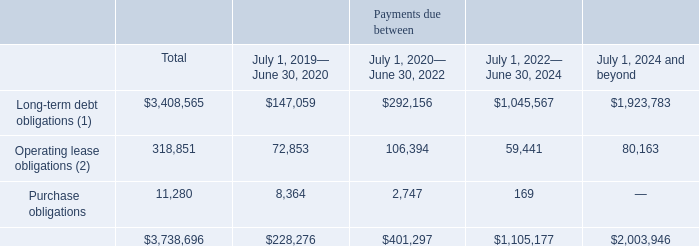NOTE 13—GUARANTEES AND CONTINGENCIES
We have entered into the following contractual obligations with minimum payments for the indicated fiscal periods as follows:
(1) Includes interest up to maturity and principal payments. Please see note 10 "Long-Term Debt" for more details
(2) Net of $30.7 million of sublease income to be received from properties which we have subleased to third parties.
What does the table represent? Contractual obligations with minimum payments for the indicated fiscal periods. What is Operating lease obligations net of? $30.7 million of sublease income. What does Long-term debt obligations include? Interest up to maturity and principal payments. What is the Total Operating lease obligations expressed as a percentage of Total obligations?
Answer scale should be: percent. 318,851/3,738,696
Answer: 8.53. In what year range(s) are Operating lease obligations more than $100,000(in thousands)? For row 4 if value >100,000 the corresponding year range at row 2 is selected
Answer: july 1, 2020— june 30, 2022. What is the total obligations of July 1, 2024 and beyond expressed as a percentage of total obligations for July 1, 2019-June 30, 2024?
Answer scale should be: percent. 2,003,946/(3,738,696-2,003,946)
Answer: 115.52. 